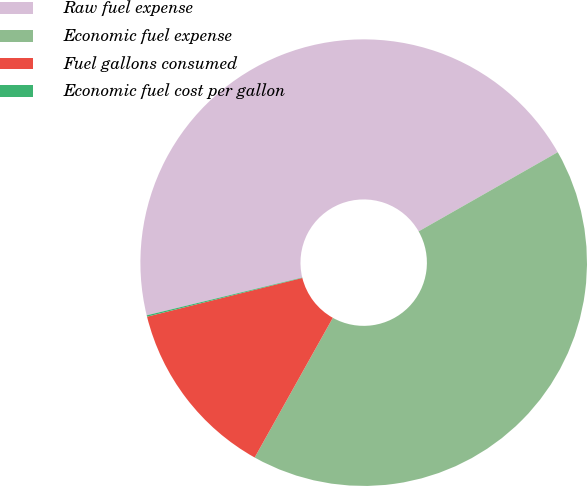<chart> <loc_0><loc_0><loc_500><loc_500><pie_chart><fcel>Raw fuel expense<fcel>Economic fuel expense<fcel>Fuel gallons consumed<fcel>Economic fuel cost per gallon<nl><fcel>45.55%<fcel>41.35%<fcel>12.99%<fcel>0.1%<nl></chart> 